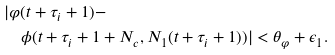Convert formula to latex. <formula><loc_0><loc_0><loc_500><loc_500>& | \varphi ( t + \tau _ { i } + 1 ) - \\ & \quad \phi ( t + \tau _ { i } + 1 + N _ { c } , N _ { 1 } ( t + \tau _ { i } + 1 ) ) | < \theta _ { \varphi } + \epsilon _ { 1 } .</formula> 